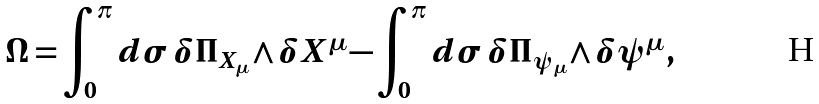Convert formula to latex. <formula><loc_0><loc_0><loc_500><loc_500>\Omega = \int _ { 0 } ^ { \pi } d { \sigma } \, \delta \Pi _ { X _ { \mu } } \wedge \delta X ^ { \mu } - \int _ { 0 } ^ { \pi } d { \sigma } \, \delta \Pi _ { \psi _ { \mu } } \wedge \delta \psi ^ { \mu } \, ,</formula> 